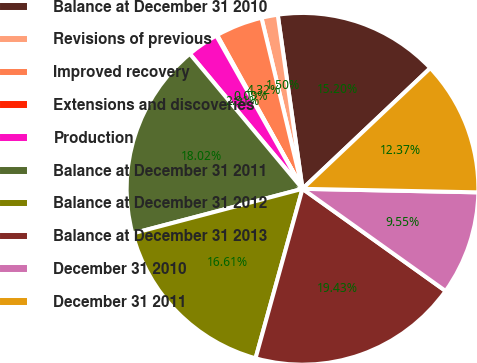Convert chart. <chart><loc_0><loc_0><loc_500><loc_500><pie_chart><fcel>Balance at December 31 2010<fcel>Revisions of previous<fcel>Improved recovery<fcel>Extensions and discoveries<fcel>Production<fcel>Balance at December 31 2011<fcel>Balance at December 31 2012<fcel>Balance at December 31 2013<fcel>December 31 2010<fcel>December 31 2011<nl><fcel>15.2%<fcel>1.5%<fcel>4.32%<fcel>0.09%<fcel>2.91%<fcel>18.02%<fcel>16.61%<fcel>19.43%<fcel>9.55%<fcel>12.37%<nl></chart> 